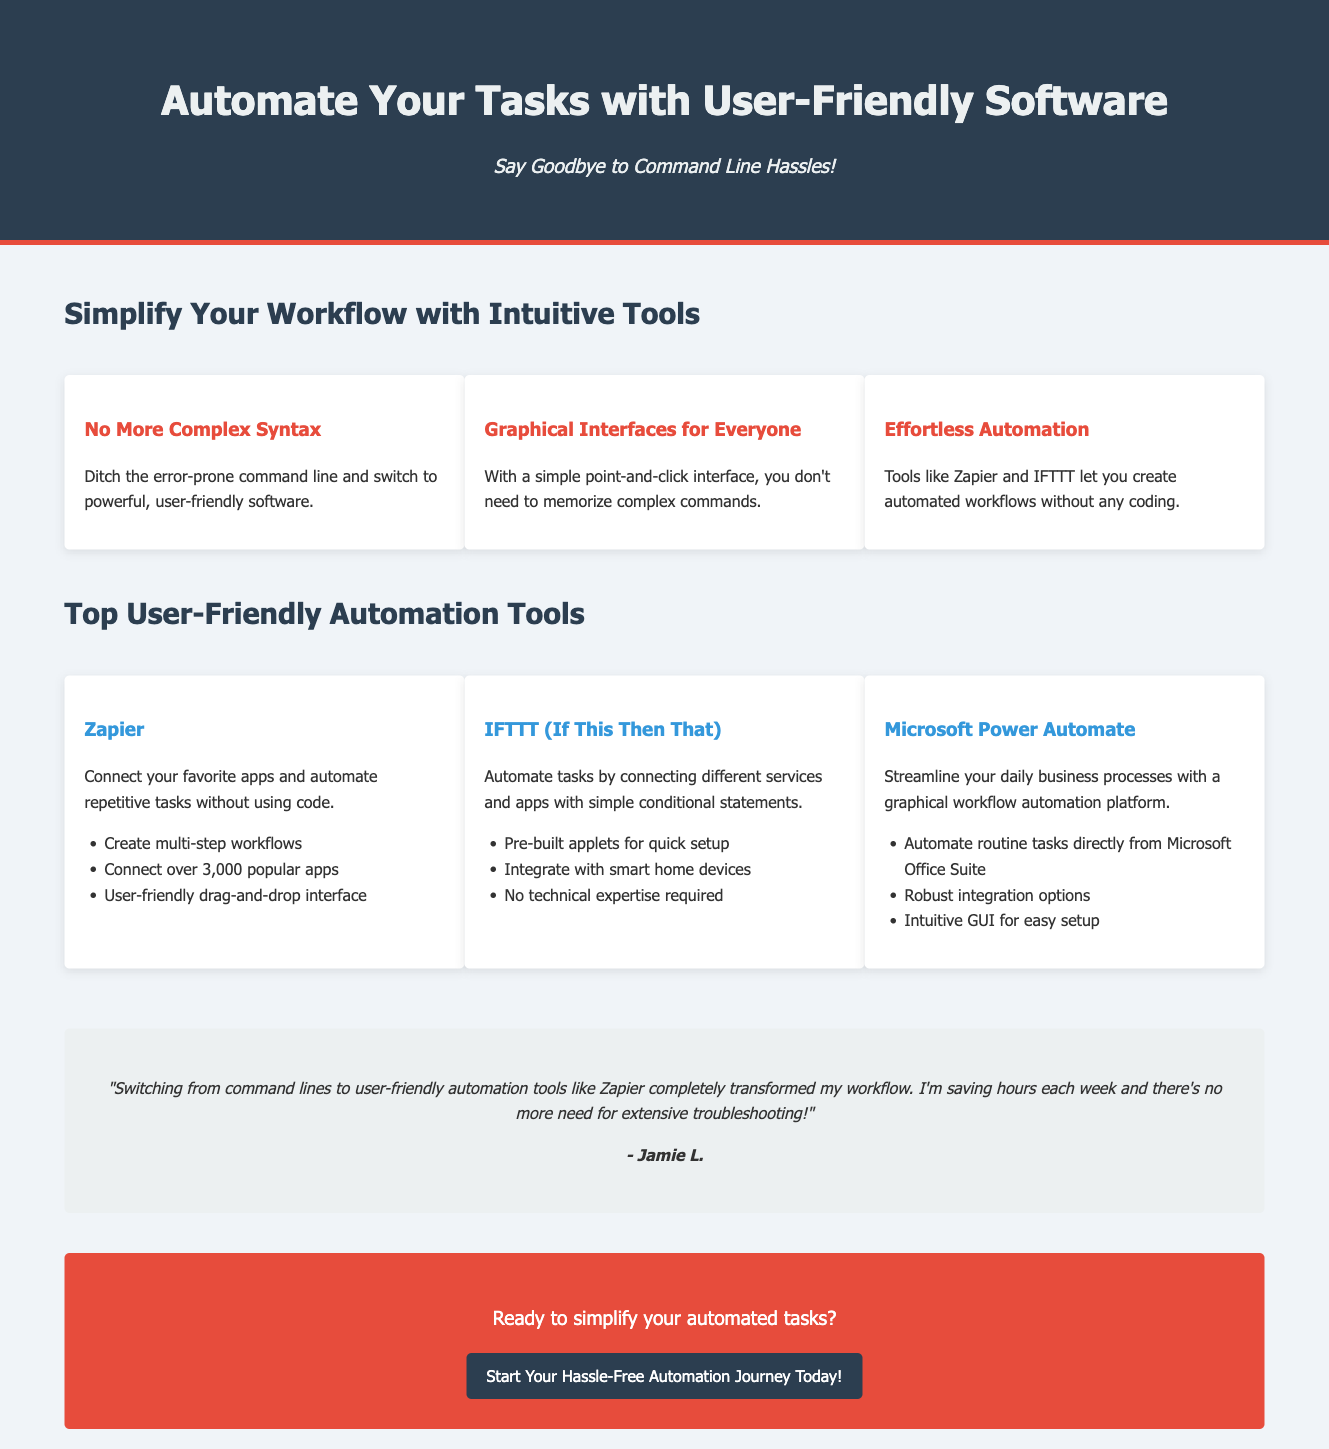What is the title of the advertisement? The title is prominently displayed in the header section of the document.
Answer: Automate Your Tasks: Say Goodbye to Command Line Hassles! What is the main benefit of using user-friendly software? This benefit is highlighted in the introductory section of the document.
Answer: No More Complex Syntax Which tool is mentioned for connecting favorite apps? This information can be found in the section showcasing user-friendly automation tools.
Answer: Zapier How many popular apps can Zapier connect to? The number of apps is listed in the description of Zapier.
Answer: over 3,000 Who provided the testimonial? The testimonial section includes the name of the person who shared their experience.
Answer: Jamie L What type of interface does IFTTT use? This information is specified in the description of the IFTTT tool.
Answer: Simple conditional statements What color is used for the call-to-action button? The design details for the button are described visually in the document.
Answer: #2c3e50 What is the purpose of Microsoft Power Automate? The purpose is stated in the section highlighting automation tools.
Answer: Streamline your daily business processes What do you need to start your hassle-free automation journey? This is suggested in the call-to-action section of the advertisement.
Answer: Ready to simplify your automated tasks? 